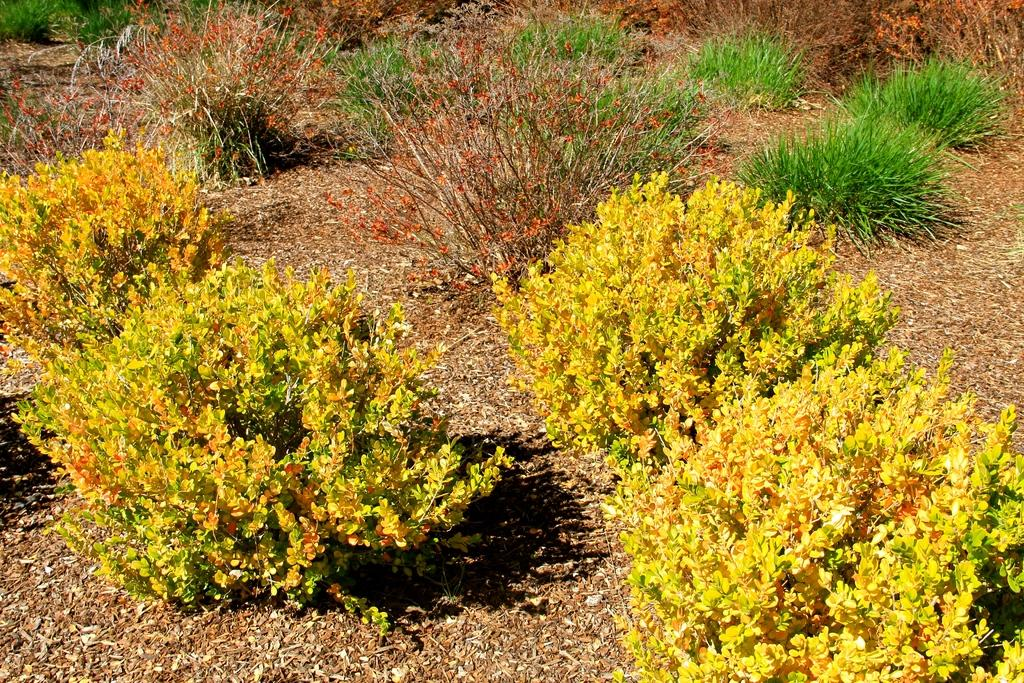What type of vegetation is present on the ground in the image? There are plants on the ground in the image. What other natural element can be seen in the image? There is grass visible in the top right of the image. What type of coal is visible in the image? There is no coal present in the image. Can you find a receipt in the image? There is no receipt present in the image. 